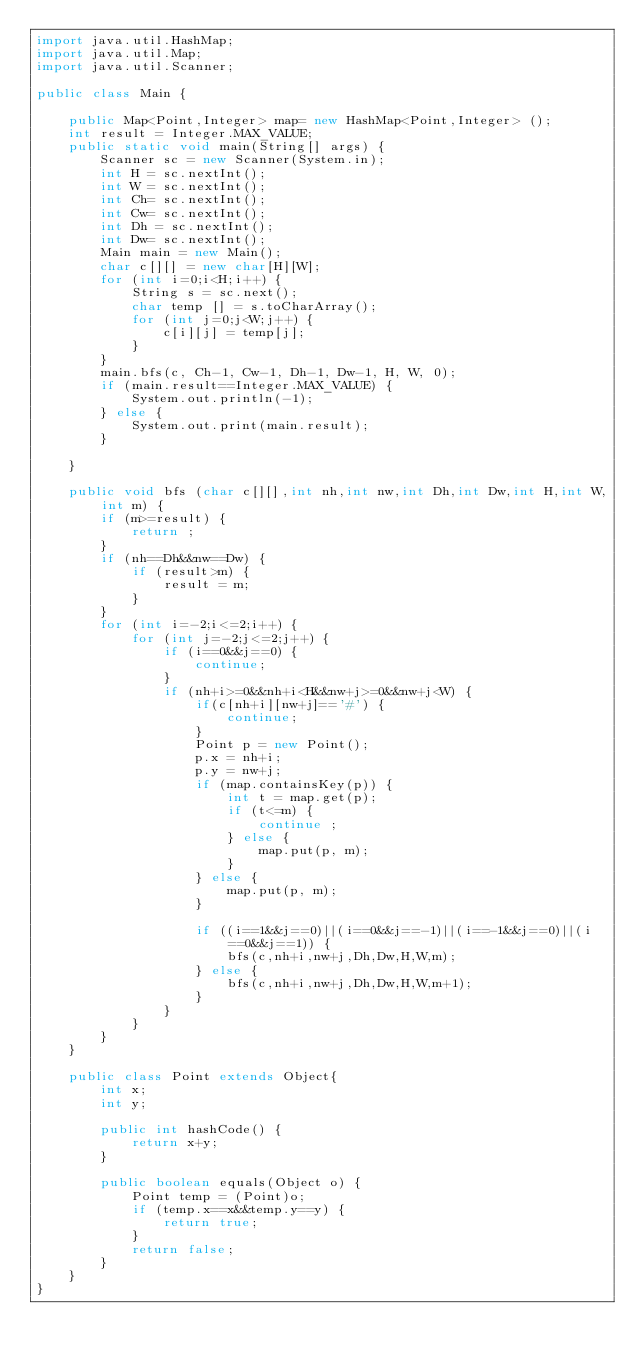Convert code to text. <code><loc_0><loc_0><loc_500><loc_500><_Java_>import java.util.HashMap;
import java.util.Map;
import java.util.Scanner;

public class Main {

	public Map<Point,Integer> map= new HashMap<Point,Integer> ();
	int result = Integer.MAX_VALUE;
	public static void main(String[] args) {
		Scanner sc = new Scanner(System.in);
		int H = sc.nextInt();
		int W = sc.nextInt();
		int Ch= sc.nextInt();
		int Cw= sc.nextInt();
		int Dh = sc.nextInt();
		int Dw= sc.nextInt();
		Main main = new Main();
		char c[][] = new char[H][W];
		for (int i=0;i<H;i++) {
			String s = sc.next();
			char temp [] = s.toCharArray();
			for (int j=0;j<W;j++) {
				c[i][j] = temp[j];
			}
		}
		main.bfs(c, Ch-1, Cw-1, Dh-1, Dw-1, H, W, 0);
		if (main.result==Integer.MAX_VALUE) {
			System.out.println(-1);
		} else {
			System.out.print(main.result);
		}

	}

	public void bfs (char c[][],int nh,int nw,int Dh,int Dw,int H,int W,int m) {
		if (m>=result) {
			return ;
		}
		if (nh==Dh&&nw==Dw) {
			if (result>m) {
				result = m;
			}
		}
		for (int i=-2;i<=2;i++) {
			for (int j=-2;j<=2;j++) {
				if (i==0&&j==0) {
					continue;
				}
				if (nh+i>=0&&nh+i<H&&nw+j>=0&&nw+j<W) {
					if(c[nh+i][nw+j]=='#') {
						continue;
					}
					Point p = new Point();
					p.x = nh+i;
					p.y = nw+j;
					if (map.containsKey(p)) {
						int t = map.get(p);
						if (t<=m) {
							continue ;
						} else {
							map.put(p, m);
						}
					} else {
						map.put(p, m);
					}

					if ((i==1&&j==0)||(i==0&&j==-1)||(i==-1&&j==0)||(i==0&&j==1)) {
						bfs(c,nh+i,nw+j,Dh,Dw,H,W,m);
					} else {
						bfs(c,nh+i,nw+j,Dh,Dw,H,W,m+1);
					}
				}
			}
		}
	}

	public class Point extends Object{
		int x;
		int y;

		public int hashCode() {
			return x+y;
		}

		public boolean equals(Object o) {
			Point temp = (Point)o;
			if (temp.x==x&&temp.y==y) {
				return true;
			}
			return false;
		}
	}
}</code> 